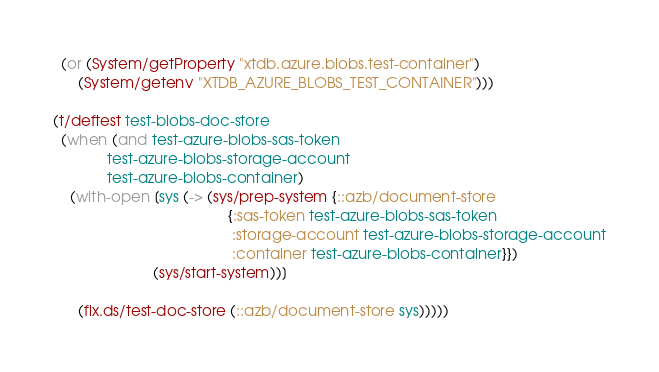<code> <loc_0><loc_0><loc_500><loc_500><_Clojure_>  (or (System/getProperty "xtdb.azure.blobs.test-container")
      (System/getenv "XTDB_AZURE_BLOBS_TEST_CONTAINER")))

(t/deftest test-blobs-doc-store
  (when (and test-azure-blobs-sas-token
             test-azure-blobs-storage-account
             test-azure-blobs-container)
    (with-open [sys (-> (sys/prep-system {::azb/document-store
                                          {:sas-token test-azure-blobs-sas-token
                                           :storage-account test-azure-blobs-storage-account
                                           :container test-azure-blobs-container}})
                        (sys/start-system))]

      (fix.ds/test-doc-store (::azb/document-store sys)))))
</code> 